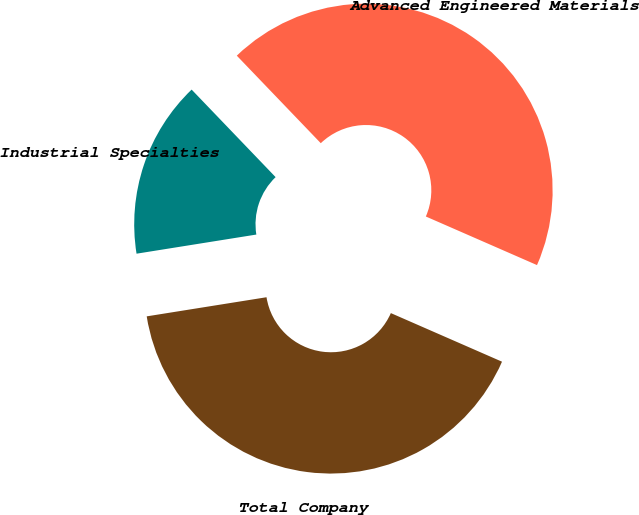Convert chart. <chart><loc_0><loc_0><loc_500><loc_500><pie_chart><fcel>Advanced Engineered Materials<fcel>Industrial Specialties<fcel>Total Company<nl><fcel>43.73%<fcel>15.35%<fcel>40.92%<nl></chart> 